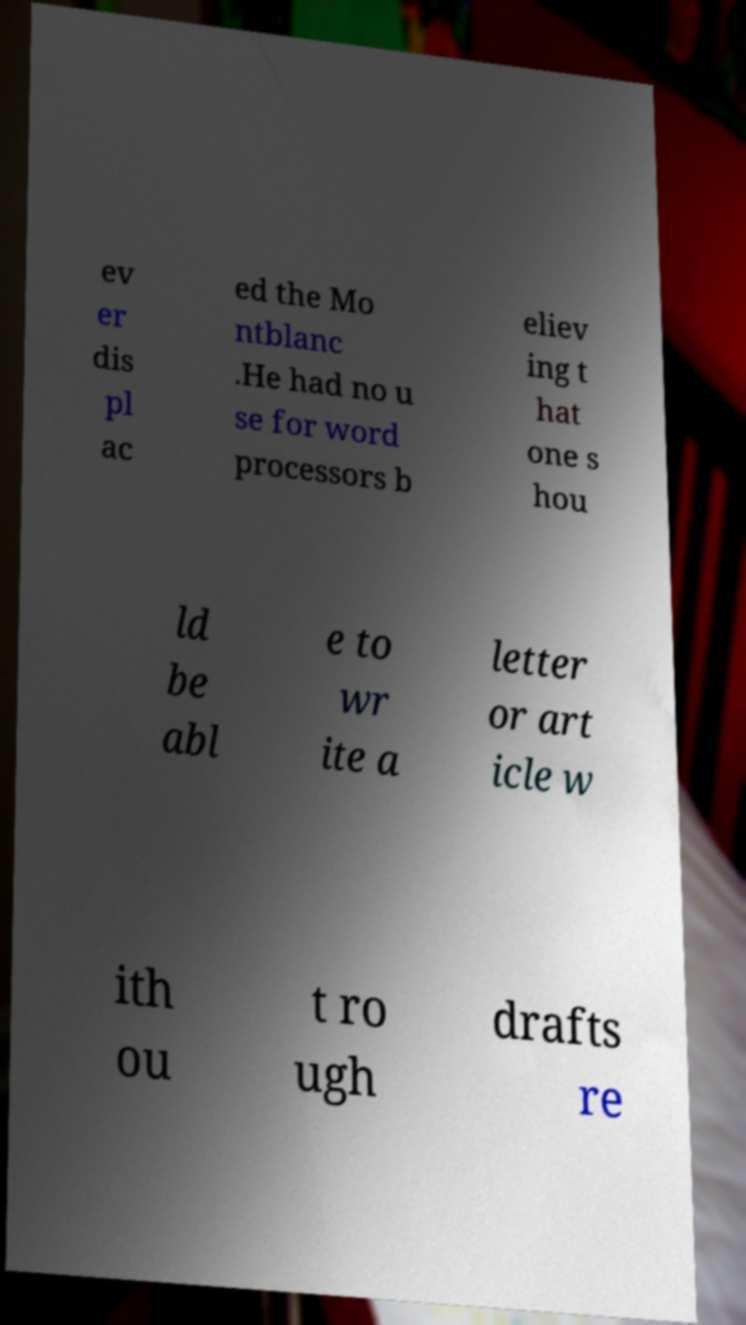What messages or text are displayed in this image? I need them in a readable, typed format. ev er dis pl ac ed the Mo ntblanc .He had no u se for word processors b eliev ing t hat one s hou ld be abl e to wr ite a letter or art icle w ith ou t ro ugh drafts re 